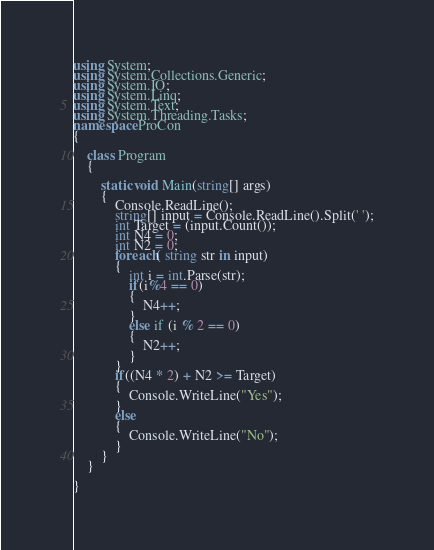Convert code to text. <code><loc_0><loc_0><loc_500><loc_500><_C#_>using System;
using System.Collections.Generic;
using System.IO;
using System.Linq;
using System.Text;
using System.Threading.Tasks;
namespace ProCon
{

    class Program
    {

        static void Main(string[] args)
        {
            Console.ReadLine();
            string[] input = Console.ReadLine().Split(' ');
            int Target = (input.Count());
            int N4 = 0;
            int N2 = 0;
            foreach( string str in input)
            {
                int i = int.Parse(str);
                if(i%4 == 0)
                {
                    N4++;
                }
                else if (i % 2 == 0)
                {
                    N2++;
                }
            }
            if((N4 * 2) + N2 >= Target)
            {
                Console.WriteLine("Yes");
            }
            else
            {
                Console.WriteLine("No");
            }
        }
    }

}</code> 